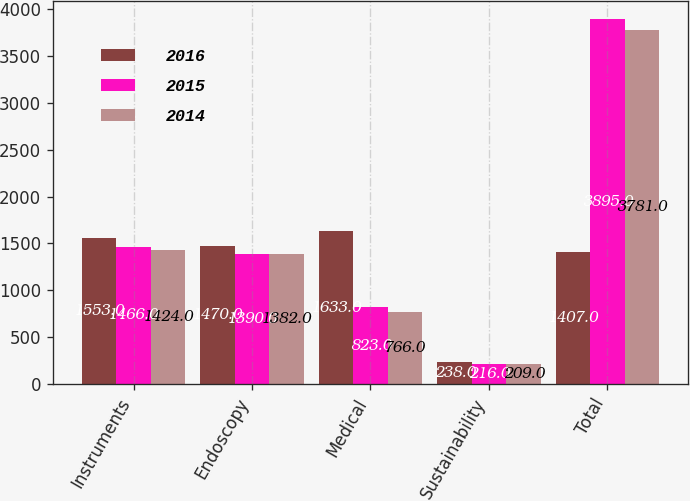<chart> <loc_0><loc_0><loc_500><loc_500><stacked_bar_chart><ecel><fcel>Instruments<fcel>Endoscopy<fcel>Medical<fcel>Sustainability<fcel>Total<nl><fcel>2016<fcel>1553<fcel>1470<fcel>1633<fcel>238<fcel>1407<nl><fcel>2015<fcel>1466<fcel>1390<fcel>823<fcel>216<fcel>3895<nl><fcel>2014<fcel>1424<fcel>1382<fcel>766<fcel>209<fcel>3781<nl></chart> 